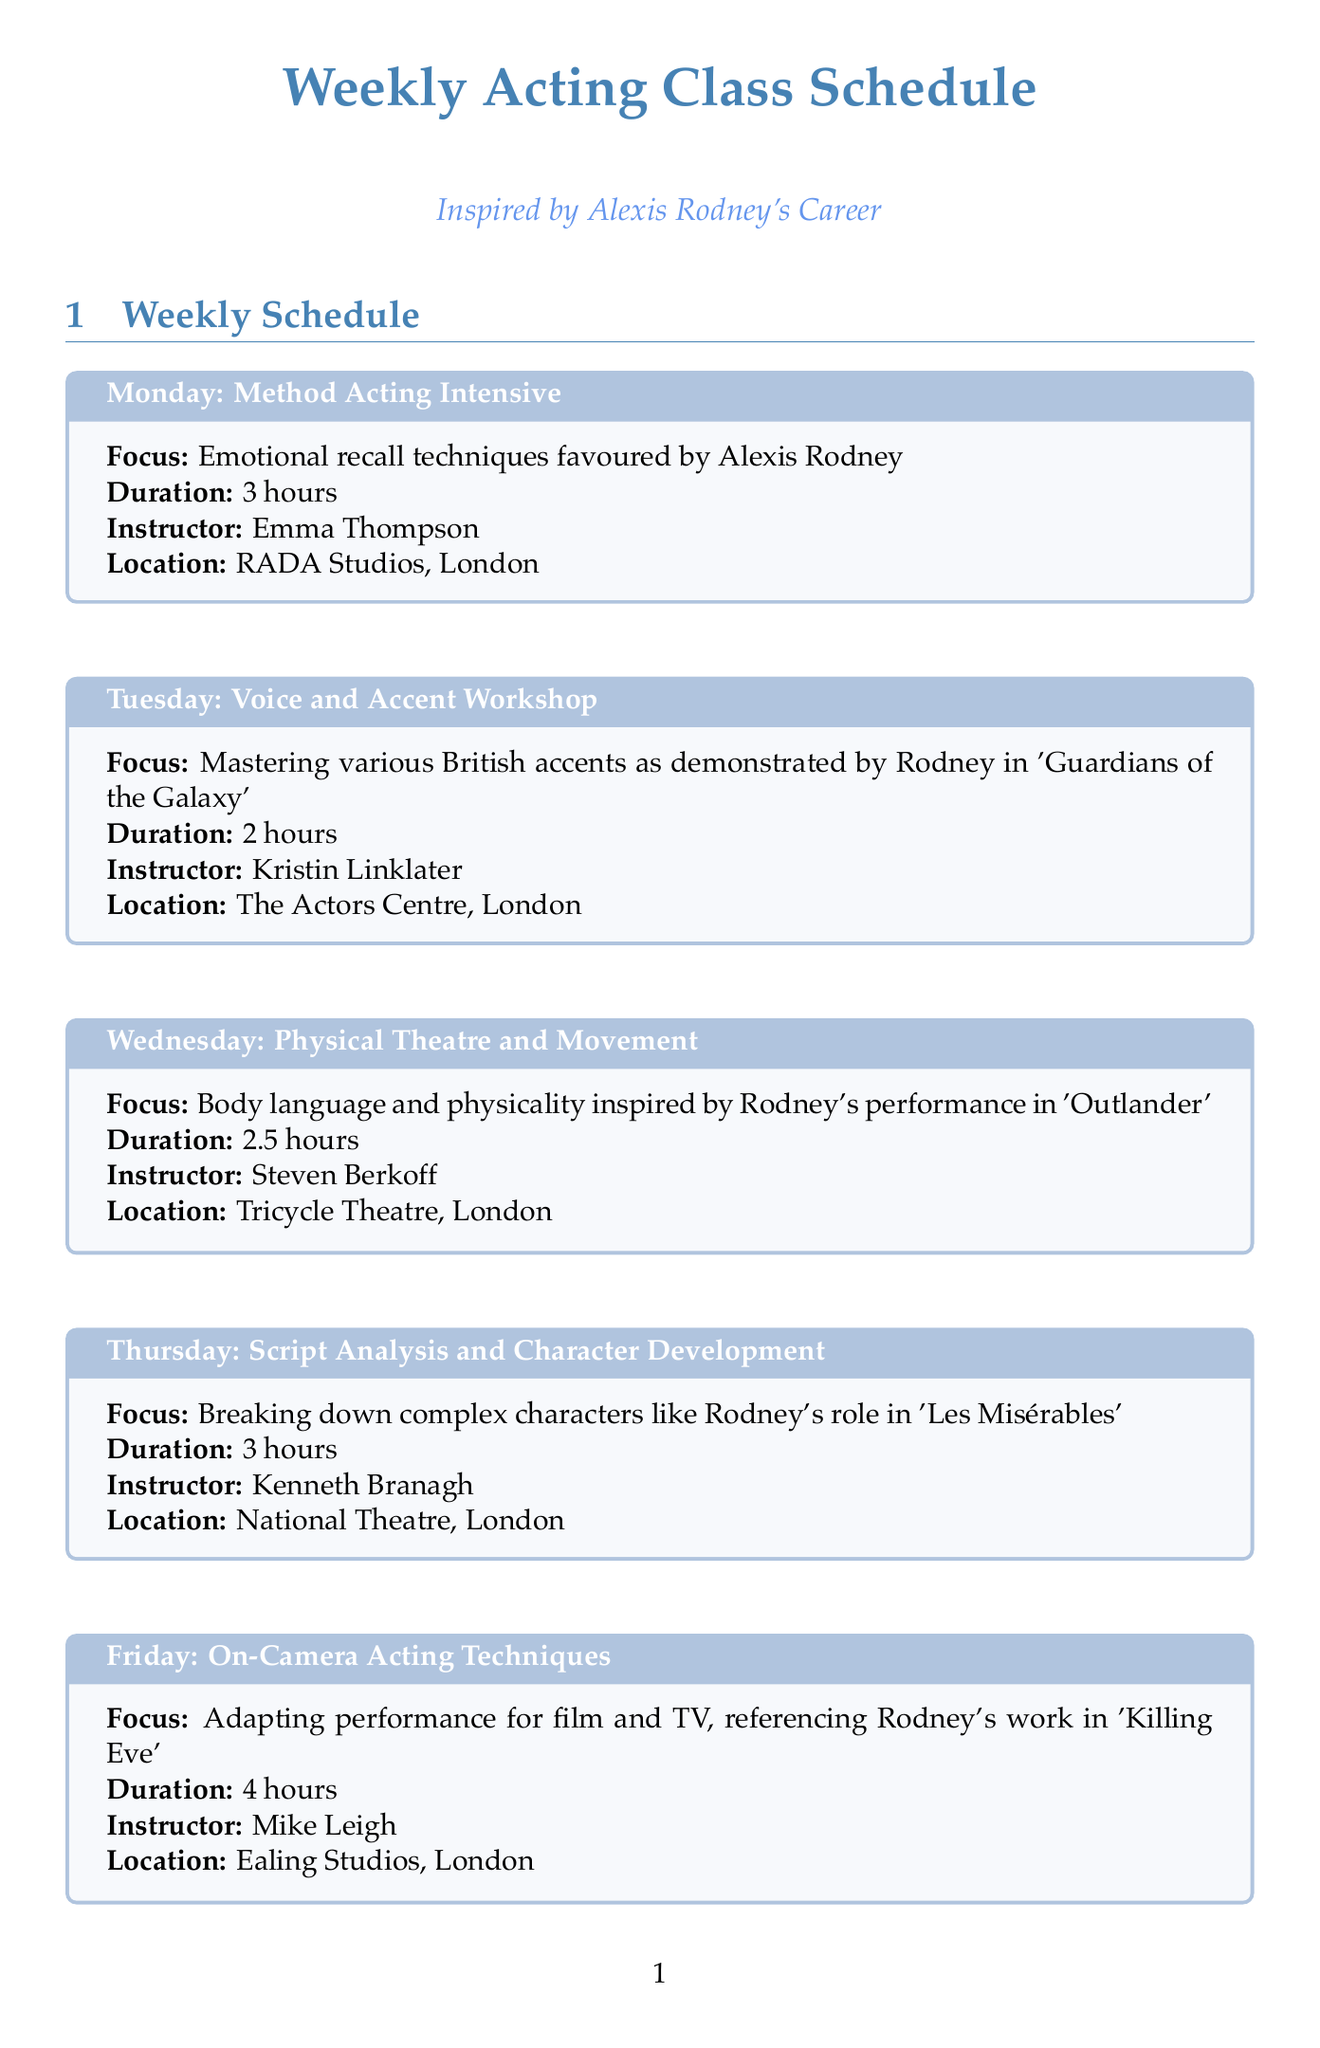What is the duration of the Method Acting Intensive class? The duration is listed in the document under the Monday class section.
Answer: 3 hours Who teaches the Voice and Accent Workshop? The information about the instructor is provided in the Tuesday class section of the document.
Answer: Kristin Linklater Which class focuses on body language and physicality? The explanation is found in the Wednesday class section, detailing what participants will learn.
Answer: Physical Theatre and Movement On which day is the Industry Insights and Career Planning class held? The day of the week for this class is specifically mentioned in the Sunday section.
Answer: Sunday What is the location of the On-Camera Acting Techniques class? This information is provided under the Friday class section in the document.
Answer: Ealing Studios, London Which acting technique does the Saturday class emphasize? The focus of this class is provided in the Saturday section, indicating the skills taught.
Answer: Improvisation and Spontaneity How long is the Script Analysis and Character Development class? The duration of this class is mentioned in the Thursday class section.
Answer: 3 hours Name one additional resource mentioned in the document. This can be found under the Additional Resources section, where various resources are listed.
Answer: An Actor Prepares What is the main focus of the Physical Theatre and Movement class? The document outlines the emphasis of this class in the Wednesday section.
Answer: Body language and physicality 